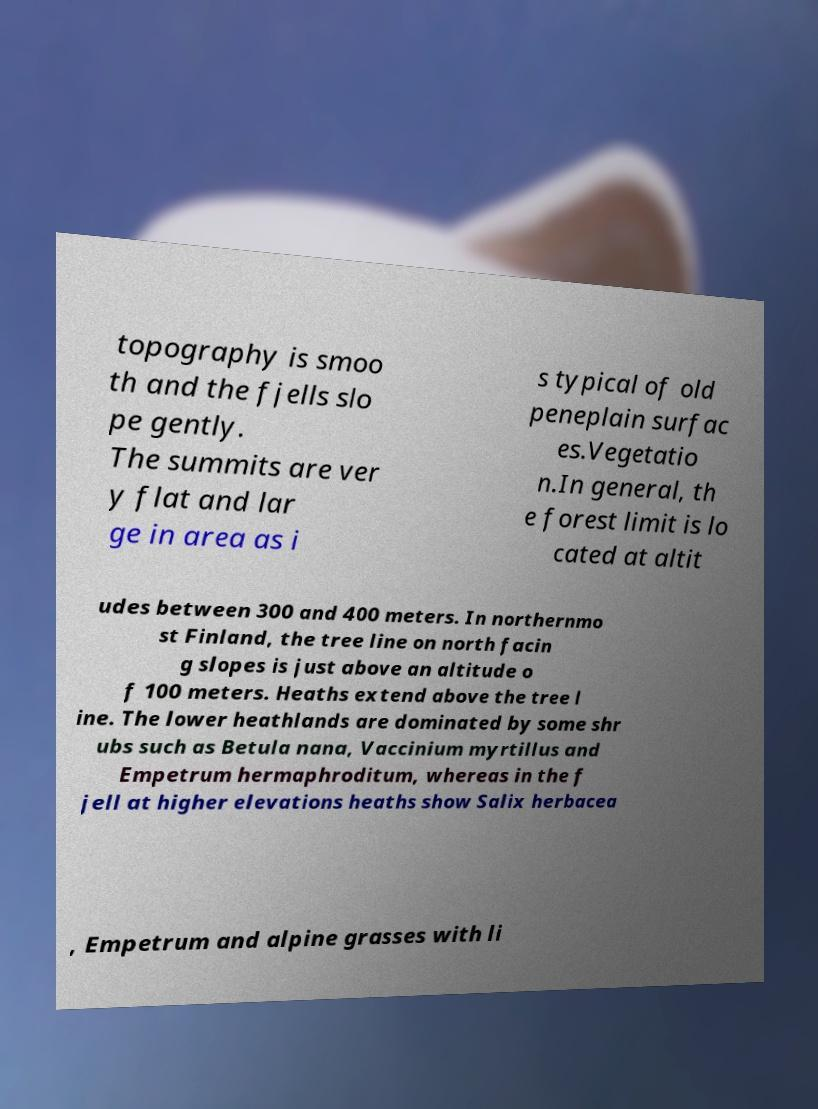Can you read and provide the text displayed in the image?This photo seems to have some interesting text. Can you extract and type it out for me? topography is smoo th and the fjells slo pe gently. The summits are ver y flat and lar ge in area as i s typical of old peneplain surfac es.Vegetatio n.In general, th e forest limit is lo cated at altit udes between 300 and 400 meters. In northernmo st Finland, the tree line on north facin g slopes is just above an altitude o f 100 meters. Heaths extend above the tree l ine. The lower heathlands are dominated by some shr ubs such as Betula nana, Vaccinium myrtillus and Empetrum hermaphroditum, whereas in the f jell at higher elevations heaths show Salix herbacea , Empetrum and alpine grasses with li 